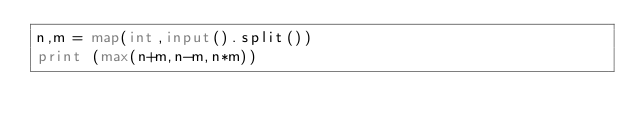<code> <loc_0><loc_0><loc_500><loc_500><_Python_>n,m = map(int,input().split())
print (max(n+m,n-m,n*m))
</code> 